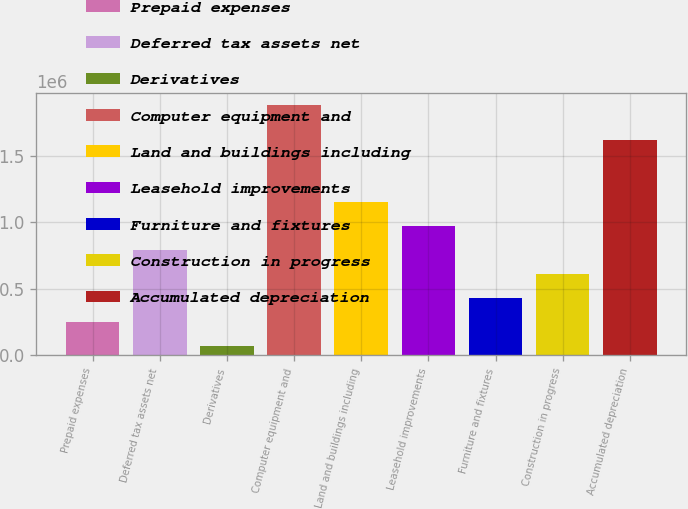Convert chart. <chart><loc_0><loc_0><loc_500><loc_500><bar_chart><fcel>Prepaid expenses<fcel>Deferred tax assets net<fcel>Derivatives<fcel>Computer equipment and<fcel>Land and buildings including<fcel>Leasehold improvements<fcel>Furniture and fixtures<fcel>Construction in progress<fcel>Accumulated depreciation<nl><fcel>251671<fcel>793237<fcel>71149<fcel>1.87637e+06<fcel>1.15428e+06<fcel>973760<fcel>432193<fcel>612715<fcel>1.6133e+06<nl></chart> 